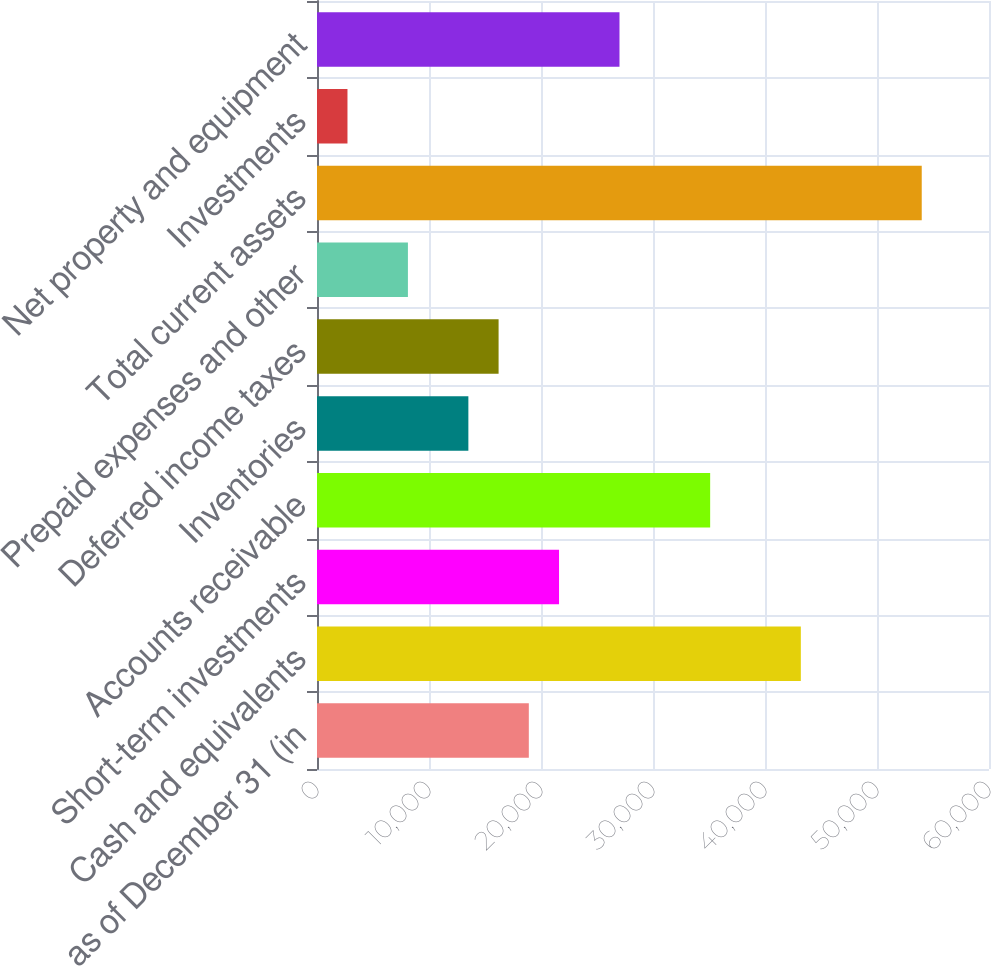Convert chart to OTSL. <chart><loc_0><loc_0><loc_500><loc_500><bar_chart><fcel>as of December 31 (in<fcel>Cash and equivalents<fcel>Short-term investments<fcel>Accounts receivable<fcel>Inventories<fcel>Deferred income taxes<fcel>Prepaid expenses and other<fcel>Total current assets<fcel>Investments<fcel>Net property and equipment<nl><fcel>18912.2<fcel>43199.6<fcel>21610.8<fcel>35103.8<fcel>13515<fcel>16213.6<fcel>8117.8<fcel>53994<fcel>2720.6<fcel>27008<nl></chart> 